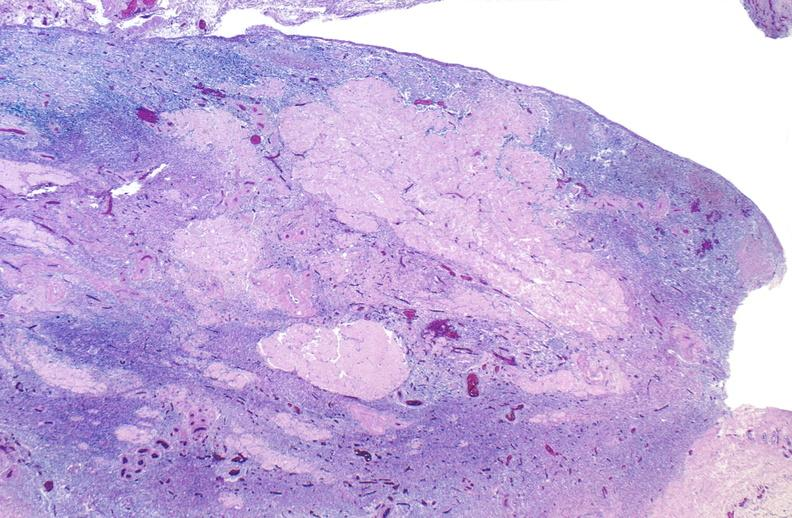where is this from?
Answer the question using a single word or phrase. Female reproductive system 